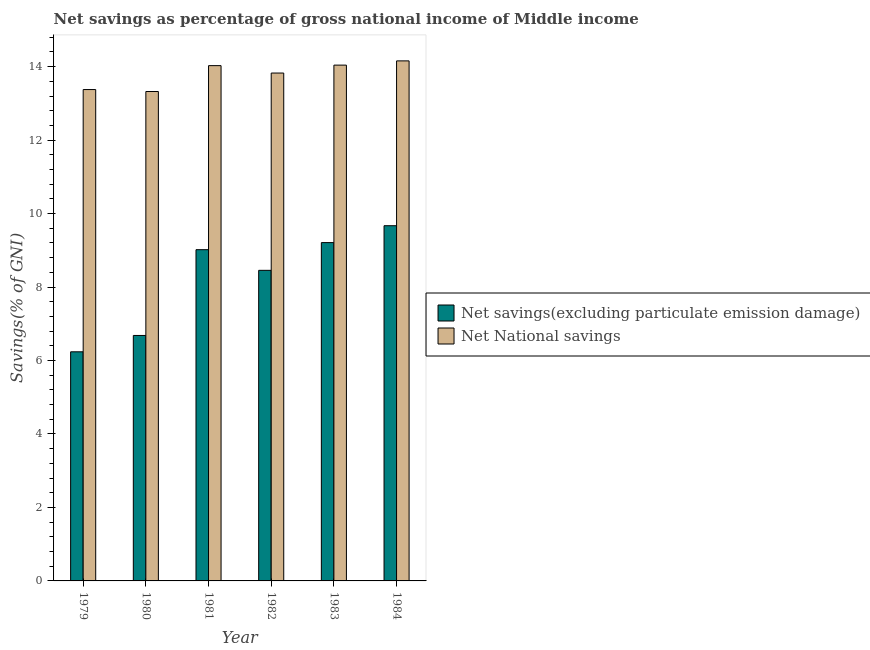How many different coloured bars are there?
Provide a succinct answer. 2. How many groups of bars are there?
Your answer should be compact. 6. Are the number of bars per tick equal to the number of legend labels?
Keep it short and to the point. Yes. How many bars are there on the 5th tick from the right?
Provide a short and direct response. 2. What is the net national savings in 1979?
Provide a succinct answer. 13.38. Across all years, what is the maximum net savings(excluding particulate emission damage)?
Provide a succinct answer. 9.67. Across all years, what is the minimum net savings(excluding particulate emission damage)?
Offer a very short reply. 6.24. In which year was the net national savings maximum?
Your answer should be compact. 1984. In which year was the net savings(excluding particulate emission damage) minimum?
Make the answer very short. 1979. What is the total net national savings in the graph?
Give a very brief answer. 82.76. What is the difference between the net savings(excluding particulate emission damage) in 1981 and that in 1982?
Offer a terse response. 0.56. What is the difference between the net savings(excluding particulate emission damage) in 1981 and the net national savings in 1982?
Give a very brief answer. 0.56. What is the average net savings(excluding particulate emission damage) per year?
Provide a succinct answer. 8.21. In the year 1982, what is the difference between the net national savings and net savings(excluding particulate emission damage)?
Provide a succinct answer. 0. What is the ratio of the net savings(excluding particulate emission damage) in 1979 to that in 1983?
Your answer should be compact. 0.68. Is the net savings(excluding particulate emission damage) in 1981 less than that in 1983?
Your response must be concise. Yes. Is the difference between the net savings(excluding particulate emission damage) in 1983 and 1984 greater than the difference between the net national savings in 1983 and 1984?
Give a very brief answer. No. What is the difference between the highest and the second highest net savings(excluding particulate emission damage)?
Provide a short and direct response. 0.46. What is the difference between the highest and the lowest net national savings?
Keep it short and to the point. 0.83. In how many years, is the net savings(excluding particulate emission damage) greater than the average net savings(excluding particulate emission damage) taken over all years?
Your answer should be compact. 4. What does the 1st bar from the left in 1980 represents?
Give a very brief answer. Net savings(excluding particulate emission damage). What does the 1st bar from the right in 1983 represents?
Keep it short and to the point. Net National savings. How many bars are there?
Your response must be concise. 12. What is the difference between two consecutive major ticks on the Y-axis?
Your answer should be compact. 2. Does the graph contain grids?
Offer a terse response. No. How are the legend labels stacked?
Ensure brevity in your answer.  Vertical. What is the title of the graph?
Keep it short and to the point. Net savings as percentage of gross national income of Middle income. What is the label or title of the Y-axis?
Ensure brevity in your answer.  Savings(% of GNI). What is the Savings(% of GNI) of Net savings(excluding particulate emission damage) in 1979?
Give a very brief answer. 6.24. What is the Savings(% of GNI) in Net National savings in 1979?
Make the answer very short. 13.38. What is the Savings(% of GNI) in Net savings(excluding particulate emission damage) in 1980?
Your response must be concise. 6.68. What is the Savings(% of GNI) of Net National savings in 1980?
Offer a very short reply. 13.32. What is the Savings(% of GNI) in Net savings(excluding particulate emission damage) in 1981?
Ensure brevity in your answer.  9.02. What is the Savings(% of GNI) of Net National savings in 1981?
Your answer should be compact. 14.03. What is the Savings(% of GNI) of Net savings(excluding particulate emission damage) in 1982?
Your answer should be compact. 8.46. What is the Savings(% of GNI) of Net National savings in 1982?
Give a very brief answer. 13.83. What is the Savings(% of GNI) in Net savings(excluding particulate emission damage) in 1983?
Your response must be concise. 9.21. What is the Savings(% of GNI) of Net National savings in 1983?
Keep it short and to the point. 14.04. What is the Savings(% of GNI) in Net savings(excluding particulate emission damage) in 1984?
Give a very brief answer. 9.67. What is the Savings(% of GNI) of Net National savings in 1984?
Make the answer very short. 14.16. Across all years, what is the maximum Savings(% of GNI) of Net savings(excluding particulate emission damage)?
Your answer should be very brief. 9.67. Across all years, what is the maximum Savings(% of GNI) in Net National savings?
Ensure brevity in your answer.  14.16. Across all years, what is the minimum Savings(% of GNI) in Net savings(excluding particulate emission damage)?
Make the answer very short. 6.24. Across all years, what is the minimum Savings(% of GNI) of Net National savings?
Your answer should be compact. 13.32. What is the total Savings(% of GNI) in Net savings(excluding particulate emission damage) in the graph?
Keep it short and to the point. 49.27. What is the total Savings(% of GNI) in Net National savings in the graph?
Ensure brevity in your answer.  82.76. What is the difference between the Savings(% of GNI) of Net savings(excluding particulate emission damage) in 1979 and that in 1980?
Ensure brevity in your answer.  -0.44. What is the difference between the Savings(% of GNI) in Net National savings in 1979 and that in 1980?
Offer a terse response. 0.05. What is the difference between the Savings(% of GNI) of Net savings(excluding particulate emission damage) in 1979 and that in 1981?
Offer a terse response. -2.78. What is the difference between the Savings(% of GNI) in Net National savings in 1979 and that in 1981?
Keep it short and to the point. -0.65. What is the difference between the Savings(% of GNI) of Net savings(excluding particulate emission damage) in 1979 and that in 1982?
Provide a succinct answer. -2.22. What is the difference between the Savings(% of GNI) in Net National savings in 1979 and that in 1982?
Keep it short and to the point. -0.45. What is the difference between the Savings(% of GNI) of Net savings(excluding particulate emission damage) in 1979 and that in 1983?
Ensure brevity in your answer.  -2.97. What is the difference between the Savings(% of GNI) of Net National savings in 1979 and that in 1983?
Your answer should be compact. -0.67. What is the difference between the Savings(% of GNI) in Net savings(excluding particulate emission damage) in 1979 and that in 1984?
Provide a short and direct response. -3.43. What is the difference between the Savings(% of GNI) in Net National savings in 1979 and that in 1984?
Make the answer very short. -0.78. What is the difference between the Savings(% of GNI) of Net savings(excluding particulate emission damage) in 1980 and that in 1981?
Keep it short and to the point. -2.34. What is the difference between the Savings(% of GNI) of Net National savings in 1980 and that in 1981?
Provide a succinct answer. -0.7. What is the difference between the Savings(% of GNI) of Net savings(excluding particulate emission damage) in 1980 and that in 1982?
Give a very brief answer. -1.77. What is the difference between the Savings(% of GNI) of Net National savings in 1980 and that in 1982?
Provide a short and direct response. -0.5. What is the difference between the Savings(% of GNI) in Net savings(excluding particulate emission damage) in 1980 and that in 1983?
Provide a succinct answer. -2.53. What is the difference between the Savings(% of GNI) of Net National savings in 1980 and that in 1983?
Offer a terse response. -0.72. What is the difference between the Savings(% of GNI) in Net savings(excluding particulate emission damage) in 1980 and that in 1984?
Make the answer very short. -2.99. What is the difference between the Savings(% of GNI) in Net National savings in 1980 and that in 1984?
Keep it short and to the point. -0.83. What is the difference between the Savings(% of GNI) in Net savings(excluding particulate emission damage) in 1981 and that in 1982?
Your answer should be compact. 0.56. What is the difference between the Savings(% of GNI) in Net National savings in 1981 and that in 1982?
Provide a short and direct response. 0.2. What is the difference between the Savings(% of GNI) in Net savings(excluding particulate emission damage) in 1981 and that in 1983?
Offer a terse response. -0.19. What is the difference between the Savings(% of GNI) of Net National savings in 1981 and that in 1983?
Offer a very short reply. -0.01. What is the difference between the Savings(% of GNI) in Net savings(excluding particulate emission damage) in 1981 and that in 1984?
Give a very brief answer. -0.65. What is the difference between the Savings(% of GNI) in Net National savings in 1981 and that in 1984?
Provide a succinct answer. -0.13. What is the difference between the Savings(% of GNI) in Net savings(excluding particulate emission damage) in 1982 and that in 1983?
Offer a very short reply. -0.75. What is the difference between the Savings(% of GNI) in Net National savings in 1982 and that in 1983?
Provide a succinct answer. -0.22. What is the difference between the Savings(% of GNI) in Net savings(excluding particulate emission damage) in 1982 and that in 1984?
Make the answer very short. -1.21. What is the difference between the Savings(% of GNI) in Net National savings in 1982 and that in 1984?
Offer a very short reply. -0.33. What is the difference between the Savings(% of GNI) of Net savings(excluding particulate emission damage) in 1983 and that in 1984?
Your answer should be very brief. -0.46. What is the difference between the Savings(% of GNI) in Net National savings in 1983 and that in 1984?
Your answer should be compact. -0.12. What is the difference between the Savings(% of GNI) in Net savings(excluding particulate emission damage) in 1979 and the Savings(% of GNI) in Net National savings in 1980?
Offer a terse response. -7.09. What is the difference between the Savings(% of GNI) of Net savings(excluding particulate emission damage) in 1979 and the Savings(% of GNI) of Net National savings in 1981?
Keep it short and to the point. -7.79. What is the difference between the Savings(% of GNI) of Net savings(excluding particulate emission damage) in 1979 and the Savings(% of GNI) of Net National savings in 1982?
Provide a short and direct response. -7.59. What is the difference between the Savings(% of GNI) of Net savings(excluding particulate emission damage) in 1979 and the Savings(% of GNI) of Net National savings in 1983?
Give a very brief answer. -7.8. What is the difference between the Savings(% of GNI) of Net savings(excluding particulate emission damage) in 1979 and the Savings(% of GNI) of Net National savings in 1984?
Provide a short and direct response. -7.92. What is the difference between the Savings(% of GNI) in Net savings(excluding particulate emission damage) in 1980 and the Savings(% of GNI) in Net National savings in 1981?
Offer a terse response. -7.35. What is the difference between the Savings(% of GNI) of Net savings(excluding particulate emission damage) in 1980 and the Savings(% of GNI) of Net National savings in 1982?
Ensure brevity in your answer.  -7.14. What is the difference between the Savings(% of GNI) of Net savings(excluding particulate emission damage) in 1980 and the Savings(% of GNI) of Net National savings in 1983?
Offer a very short reply. -7.36. What is the difference between the Savings(% of GNI) of Net savings(excluding particulate emission damage) in 1980 and the Savings(% of GNI) of Net National savings in 1984?
Keep it short and to the point. -7.48. What is the difference between the Savings(% of GNI) in Net savings(excluding particulate emission damage) in 1981 and the Savings(% of GNI) in Net National savings in 1982?
Keep it short and to the point. -4.81. What is the difference between the Savings(% of GNI) in Net savings(excluding particulate emission damage) in 1981 and the Savings(% of GNI) in Net National savings in 1983?
Your answer should be compact. -5.02. What is the difference between the Savings(% of GNI) of Net savings(excluding particulate emission damage) in 1981 and the Savings(% of GNI) of Net National savings in 1984?
Your response must be concise. -5.14. What is the difference between the Savings(% of GNI) in Net savings(excluding particulate emission damage) in 1982 and the Savings(% of GNI) in Net National savings in 1983?
Make the answer very short. -5.59. What is the difference between the Savings(% of GNI) of Net savings(excluding particulate emission damage) in 1982 and the Savings(% of GNI) of Net National savings in 1984?
Your answer should be compact. -5.7. What is the difference between the Savings(% of GNI) in Net savings(excluding particulate emission damage) in 1983 and the Savings(% of GNI) in Net National savings in 1984?
Ensure brevity in your answer.  -4.95. What is the average Savings(% of GNI) in Net savings(excluding particulate emission damage) per year?
Provide a short and direct response. 8.21. What is the average Savings(% of GNI) of Net National savings per year?
Your answer should be very brief. 13.79. In the year 1979, what is the difference between the Savings(% of GNI) of Net savings(excluding particulate emission damage) and Savings(% of GNI) of Net National savings?
Give a very brief answer. -7.14. In the year 1980, what is the difference between the Savings(% of GNI) in Net savings(excluding particulate emission damage) and Savings(% of GNI) in Net National savings?
Your answer should be very brief. -6.64. In the year 1981, what is the difference between the Savings(% of GNI) in Net savings(excluding particulate emission damage) and Savings(% of GNI) in Net National savings?
Your answer should be very brief. -5.01. In the year 1982, what is the difference between the Savings(% of GNI) of Net savings(excluding particulate emission damage) and Savings(% of GNI) of Net National savings?
Make the answer very short. -5.37. In the year 1983, what is the difference between the Savings(% of GNI) in Net savings(excluding particulate emission damage) and Savings(% of GNI) in Net National savings?
Offer a terse response. -4.83. In the year 1984, what is the difference between the Savings(% of GNI) of Net savings(excluding particulate emission damage) and Savings(% of GNI) of Net National savings?
Make the answer very short. -4.49. What is the ratio of the Savings(% of GNI) of Net savings(excluding particulate emission damage) in 1979 to that in 1980?
Your response must be concise. 0.93. What is the ratio of the Savings(% of GNI) in Net savings(excluding particulate emission damage) in 1979 to that in 1981?
Provide a short and direct response. 0.69. What is the ratio of the Savings(% of GNI) in Net National savings in 1979 to that in 1981?
Offer a terse response. 0.95. What is the ratio of the Savings(% of GNI) in Net savings(excluding particulate emission damage) in 1979 to that in 1982?
Ensure brevity in your answer.  0.74. What is the ratio of the Savings(% of GNI) of Net National savings in 1979 to that in 1982?
Provide a succinct answer. 0.97. What is the ratio of the Savings(% of GNI) of Net savings(excluding particulate emission damage) in 1979 to that in 1983?
Keep it short and to the point. 0.68. What is the ratio of the Savings(% of GNI) in Net National savings in 1979 to that in 1983?
Keep it short and to the point. 0.95. What is the ratio of the Savings(% of GNI) in Net savings(excluding particulate emission damage) in 1979 to that in 1984?
Make the answer very short. 0.65. What is the ratio of the Savings(% of GNI) in Net National savings in 1979 to that in 1984?
Give a very brief answer. 0.94. What is the ratio of the Savings(% of GNI) in Net savings(excluding particulate emission damage) in 1980 to that in 1981?
Offer a terse response. 0.74. What is the ratio of the Savings(% of GNI) of Net National savings in 1980 to that in 1981?
Your answer should be very brief. 0.95. What is the ratio of the Savings(% of GNI) in Net savings(excluding particulate emission damage) in 1980 to that in 1982?
Keep it short and to the point. 0.79. What is the ratio of the Savings(% of GNI) of Net National savings in 1980 to that in 1982?
Your response must be concise. 0.96. What is the ratio of the Savings(% of GNI) in Net savings(excluding particulate emission damage) in 1980 to that in 1983?
Make the answer very short. 0.73. What is the ratio of the Savings(% of GNI) in Net National savings in 1980 to that in 1983?
Provide a succinct answer. 0.95. What is the ratio of the Savings(% of GNI) in Net savings(excluding particulate emission damage) in 1980 to that in 1984?
Provide a short and direct response. 0.69. What is the ratio of the Savings(% of GNI) of Net National savings in 1980 to that in 1984?
Give a very brief answer. 0.94. What is the ratio of the Savings(% of GNI) of Net savings(excluding particulate emission damage) in 1981 to that in 1982?
Your response must be concise. 1.07. What is the ratio of the Savings(% of GNI) in Net National savings in 1981 to that in 1982?
Your response must be concise. 1.01. What is the ratio of the Savings(% of GNI) of Net savings(excluding particulate emission damage) in 1981 to that in 1983?
Give a very brief answer. 0.98. What is the ratio of the Savings(% of GNI) of Net savings(excluding particulate emission damage) in 1981 to that in 1984?
Offer a terse response. 0.93. What is the ratio of the Savings(% of GNI) of Net National savings in 1981 to that in 1984?
Your answer should be compact. 0.99. What is the ratio of the Savings(% of GNI) of Net savings(excluding particulate emission damage) in 1982 to that in 1983?
Offer a terse response. 0.92. What is the ratio of the Savings(% of GNI) of Net National savings in 1982 to that in 1983?
Your answer should be compact. 0.98. What is the ratio of the Savings(% of GNI) in Net savings(excluding particulate emission damage) in 1982 to that in 1984?
Your answer should be very brief. 0.87. What is the ratio of the Savings(% of GNI) of Net National savings in 1982 to that in 1984?
Provide a succinct answer. 0.98. What is the ratio of the Savings(% of GNI) in Net savings(excluding particulate emission damage) in 1983 to that in 1984?
Your answer should be compact. 0.95. What is the difference between the highest and the second highest Savings(% of GNI) of Net savings(excluding particulate emission damage)?
Your answer should be compact. 0.46. What is the difference between the highest and the second highest Savings(% of GNI) of Net National savings?
Make the answer very short. 0.12. What is the difference between the highest and the lowest Savings(% of GNI) of Net savings(excluding particulate emission damage)?
Keep it short and to the point. 3.43. What is the difference between the highest and the lowest Savings(% of GNI) in Net National savings?
Give a very brief answer. 0.83. 